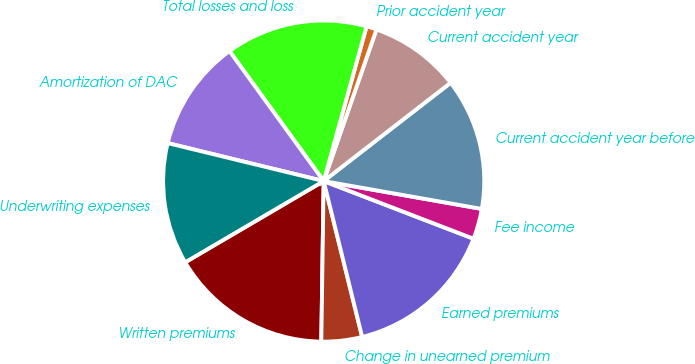<chart> <loc_0><loc_0><loc_500><loc_500><pie_chart><fcel>Written premiums<fcel>Change in unearned premium<fcel>Earned premiums<fcel>Fee income<fcel>Current accident year before<fcel>Current accident year<fcel>Prior accident year<fcel>Total losses and loss<fcel>Amortization of DAC<fcel>Underwriting expenses<nl><fcel>16.32%<fcel>4.09%<fcel>15.3%<fcel>3.07%<fcel>13.26%<fcel>9.18%<fcel>1.03%<fcel>14.28%<fcel>11.22%<fcel>12.24%<nl></chart> 